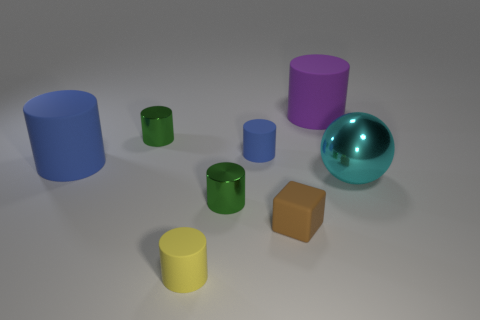Is there any other thing that is the same shape as the brown matte thing?
Your answer should be very brief. No. There is a blue object that is the same size as the brown rubber thing; what is its shape?
Your answer should be compact. Cylinder. Are there any rubber cylinders that have the same size as the yellow matte thing?
Your answer should be very brief. Yes. What material is the blue cylinder that is the same size as the cyan thing?
Provide a succinct answer. Rubber. What is the size of the green object in front of the large object right of the purple rubber object?
Provide a succinct answer. Small. Do the rubber cylinder in front of the brown thing and the brown rubber object have the same size?
Ensure brevity in your answer.  Yes. Is the number of small rubber blocks that are to the left of the tiny brown object greater than the number of small objects that are on the right side of the big cyan thing?
Provide a succinct answer. No. There is a big object that is both to the right of the small blue rubber object and left of the big cyan metallic thing; what is its shape?
Keep it short and to the point. Cylinder. What is the shape of the tiny shiny thing behind the cyan sphere?
Ensure brevity in your answer.  Cylinder. There is a blue matte thing right of the large cylinder that is to the left of the rubber cylinder in front of the tiny brown matte object; what is its size?
Offer a very short reply. Small. 